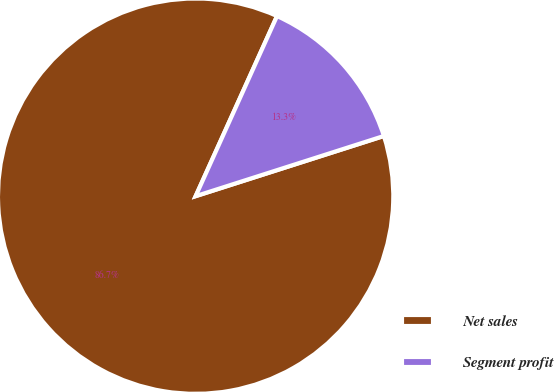Convert chart. <chart><loc_0><loc_0><loc_500><loc_500><pie_chart><fcel>Net sales<fcel>Segment profit<nl><fcel>86.68%<fcel>13.32%<nl></chart> 